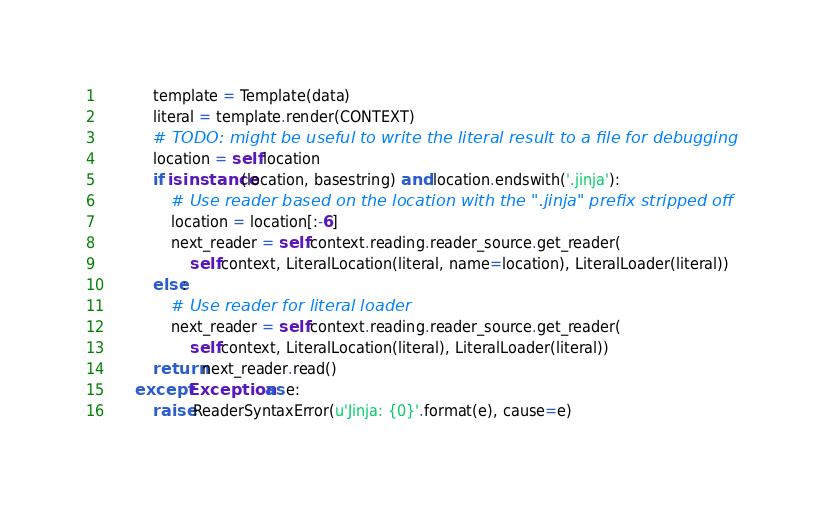Convert code to text. <code><loc_0><loc_0><loc_500><loc_500><_Python_>            template = Template(data)
            literal = template.render(CONTEXT)
            # TODO: might be useful to write the literal result to a file for debugging
            location = self.location
            if isinstance(location, basestring) and location.endswith('.jinja'):
                # Use reader based on the location with the ".jinja" prefix stripped off
                location = location[:-6]
                next_reader = self.context.reading.reader_source.get_reader(
                    self.context, LiteralLocation(literal, name=location), LiteralLoader(literal))
            else:
                # Use reader for literal loader
                next_reader = self.context.reading.reader_source.get_reader(
                    self.context, LiteralLocation(literal), LiteralLoader(literal))
            return next_reader.read()
        except Exception as e:
            raise ReaderSyntaxError(u'Jinja: {0}'.format(e), cause=e)
</code> 